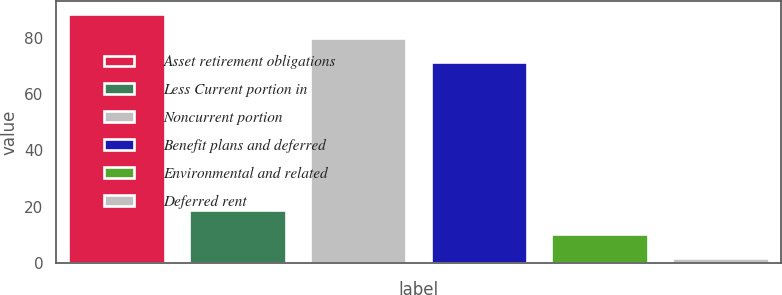Convert chart. <chart><loc_0><loc_0><loc_500><loc_500><bar_chart><fcel>Asset retirement obligations<fcel>Less Current portion in<fcel>Noncurrent portion<fcel>Benefit plans and deferred<fcel>Environmental and related<fcel>Deferred rent<nl><fcel>88.76<fcel>18.86<fcel>80.23<fcel>71.7<fcel>10.33<fcel>1.8<nl></chart> 